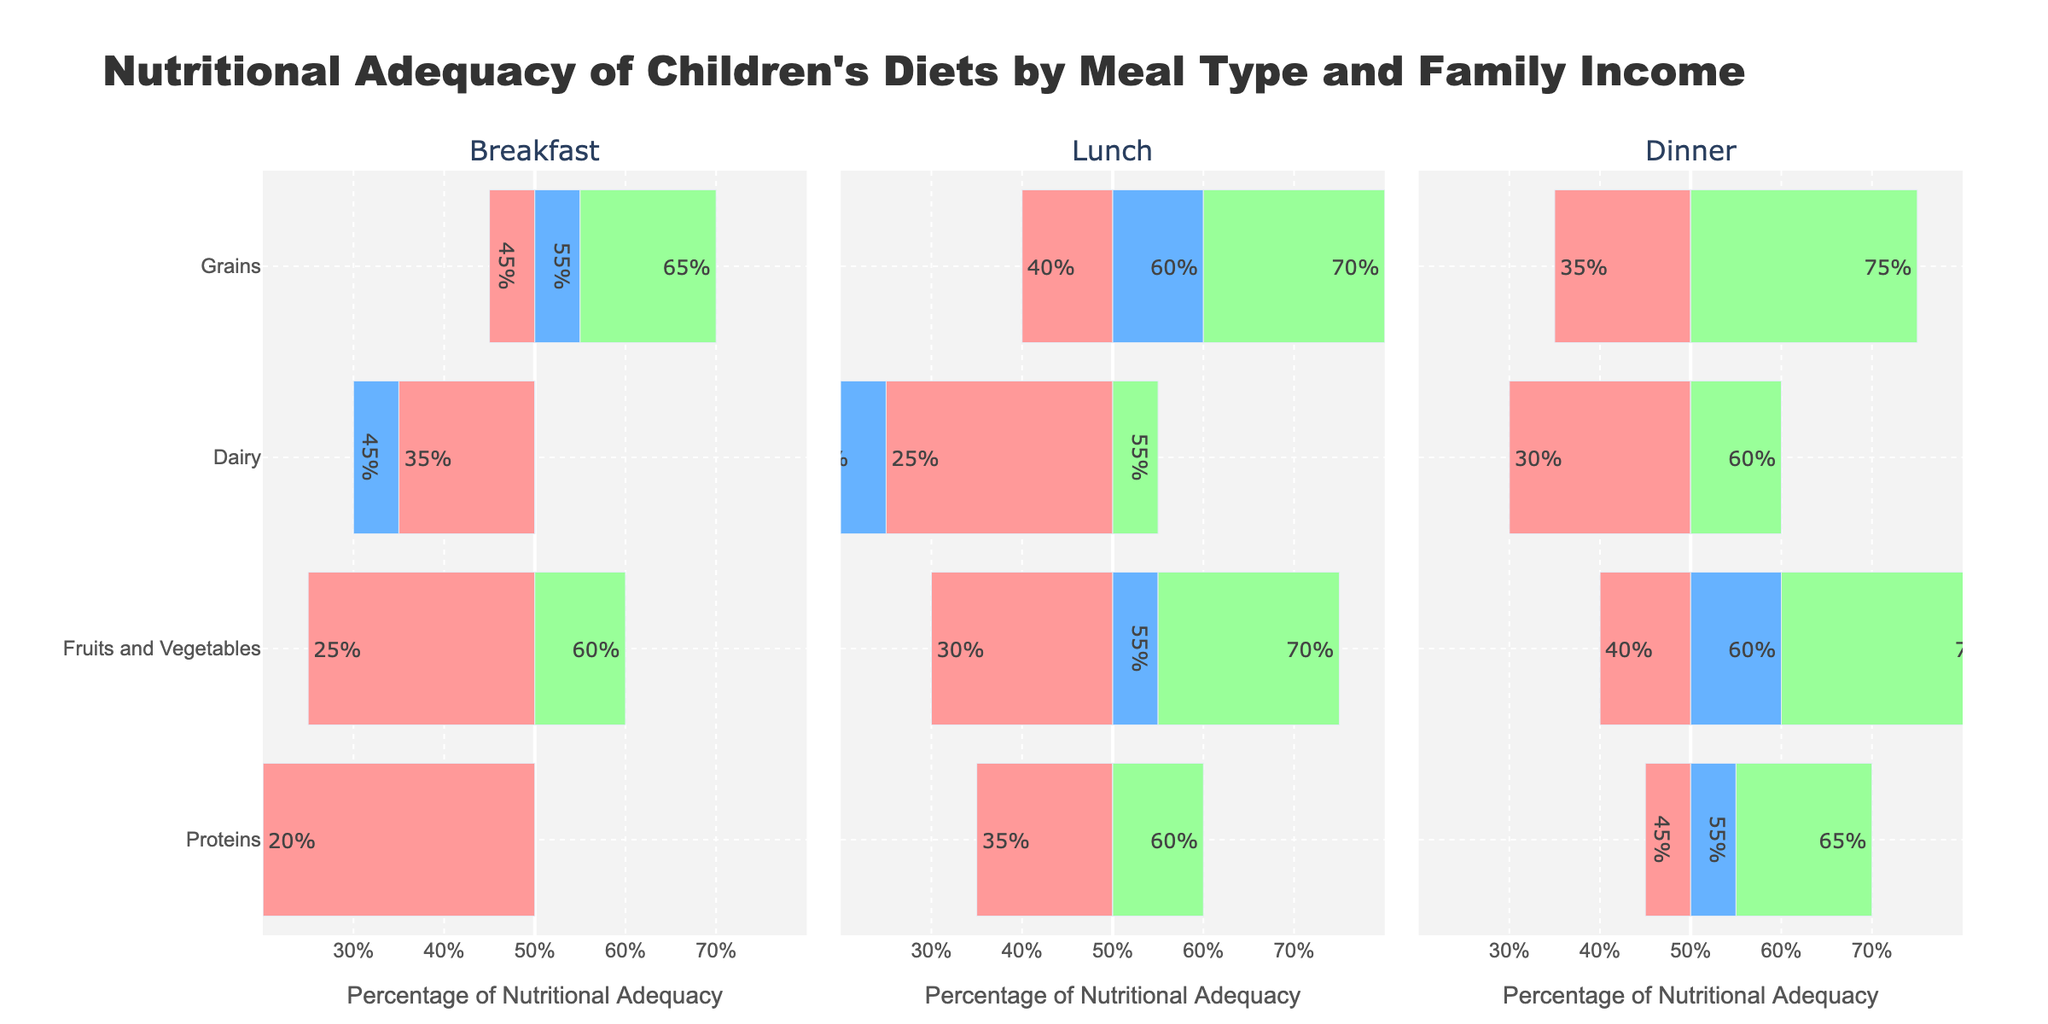What's the difference in percentage of Fruits and Vegetables consumption at Lunch between Middle and Low Income families? To find the difference, look at the percentage of Fruits and Vegetables consumption at Lunch for Middle Income (55%) and Low Income (30%) families. Subtract the smaller value from the larger one: 55% - 30% = 25%.
Answer: 25% Which meal type shows the highest percentage of Dairy consumption for High Income families? We need to examine the Dairy consumption values for High Income families across all meal types. For Breakfast, it is 50%; for Lunch, it is 55%; and for Dinner, it is 60%. The highest percentage is for Dinner.
Answer: Dinner Looking at the diagram, which category for Low Income families shows the greatest percentage of adequacy during Dinner? We should find the category with the highest percentage from the Low Income data for Dinner. The values are: Fruits and Vegetables (40%), Dairy (30%), Proteins (45%), and Grains (35%). The greatest percentage belongs to Proteins at 45%.
Answer: Proteins How does Fruits and Vegetables consumption at Breakfast for High Income families compare to Middle Income families? Check the percentage of Fruits and Vegetables for High Income (60%) and Middle Income (50%) families at Breakfast. High Income families have a 10% higher consumption than Middle Income families.
Answer: High Income families have 10% higher Which meal type has the least variation in Dairy consumption across different income levels? Review the Dairy consumption percentages for each meal type. Breakfast: Low (35%), Middle (45%), High (50%) - Variation: 50% - 35% = 15%; Lunch: Low (25%), Middle (40%), High (55%) - Variation: 55% - 25% = 30%; Dinner: Low (30%), Middle (50%), High (60%) - Variation: 60% - 30% = 30%. Breakfast has the least variation at 15%.
Answer: Breakfast What is the average percentage of Proteins consumption for Middle Income families across all meals? Identify the Proteins percentages for Middle Income families: Breakfast (30%), Lunch (50%), Dinner (55%). Sum these values: 30 + 50 + 55 = 135 and divide by the number of meals (3): 135 / 3 = 45.
Answer: 45% Which category shows the highest percentage discrepancy between High Income and Low Income families at Dinner? Look at the categories for Dinner and compute the differences: Fruits and Vegetables: 75% - 40% = 35%; Dairy: 60% - 30% = 30%; Proteins: 65% - 45% = 20%; Grains: 75% - 35% = 40%. The highest discrepancy is 40% for Grains.
Answer: Grains 